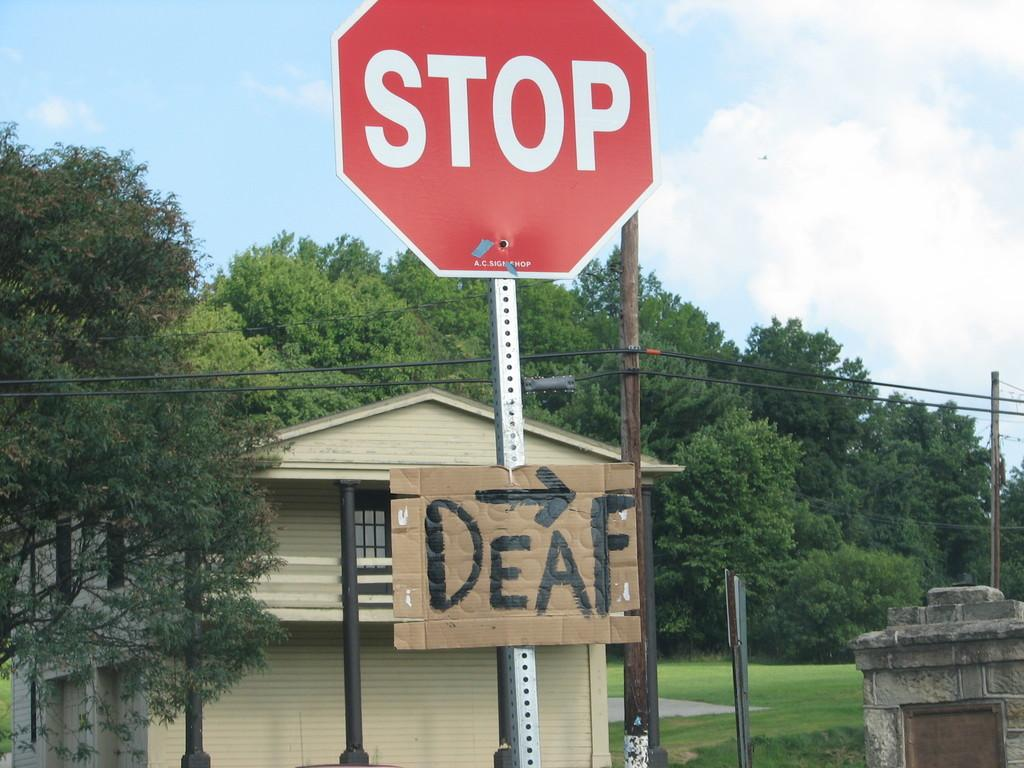<image>
Offer a succinct explanation of the picture presented. A stop sign with a cardboard sign underneath that says "Deaf". 